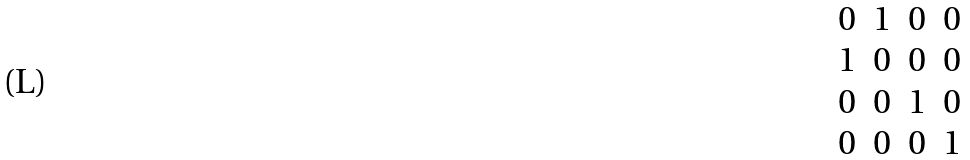<formula> <loc_0><loc_0><loc_500><loc_500>\begin{matrix} 0 & 1 & 0 & 0 \\ 1 & 0 & 0 & 0 \\ 0 & 0 & 1 & 0 \\ 0 & 0 & 0 & 1 \\ \end{matrix}</formula> 